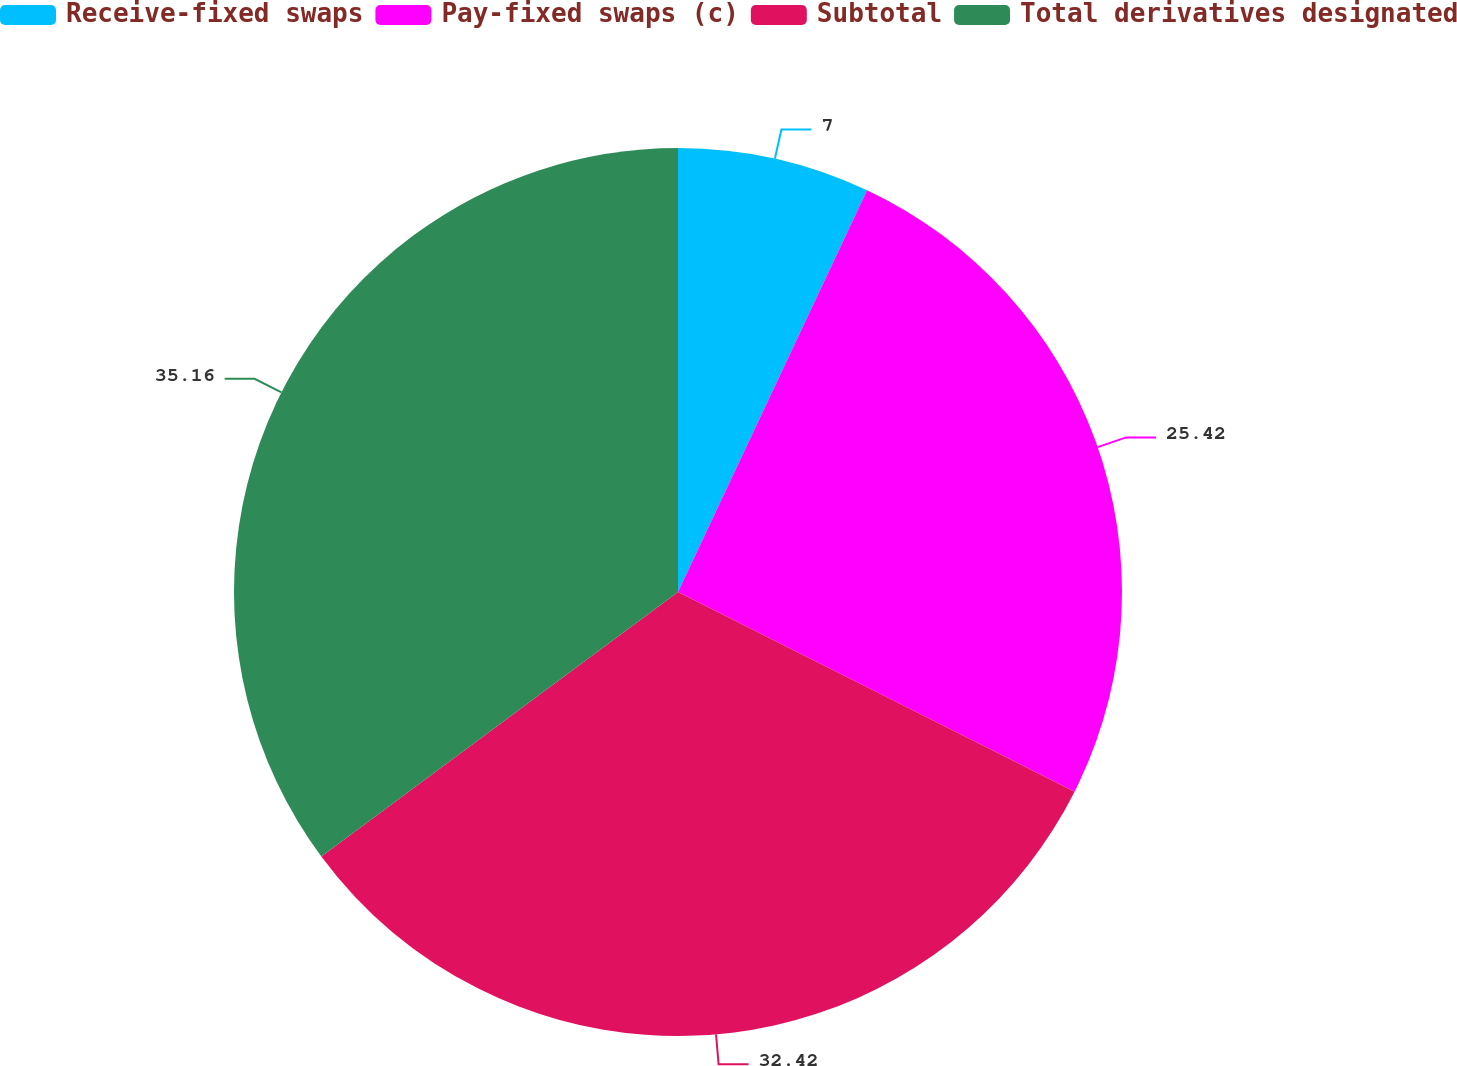<chart> <loc_0><loc_0><loc_500><loc_500><pie_chart><fcel>Receive-fixed swaps<fcel>Pay-fixed swaps (c)<fcel>Subtotal<fcel>Total derivatives designated<nl><fcel>7.0%<fcel>25.42%<fcel>32.42%<fcel>35.15%<nl></chart> 